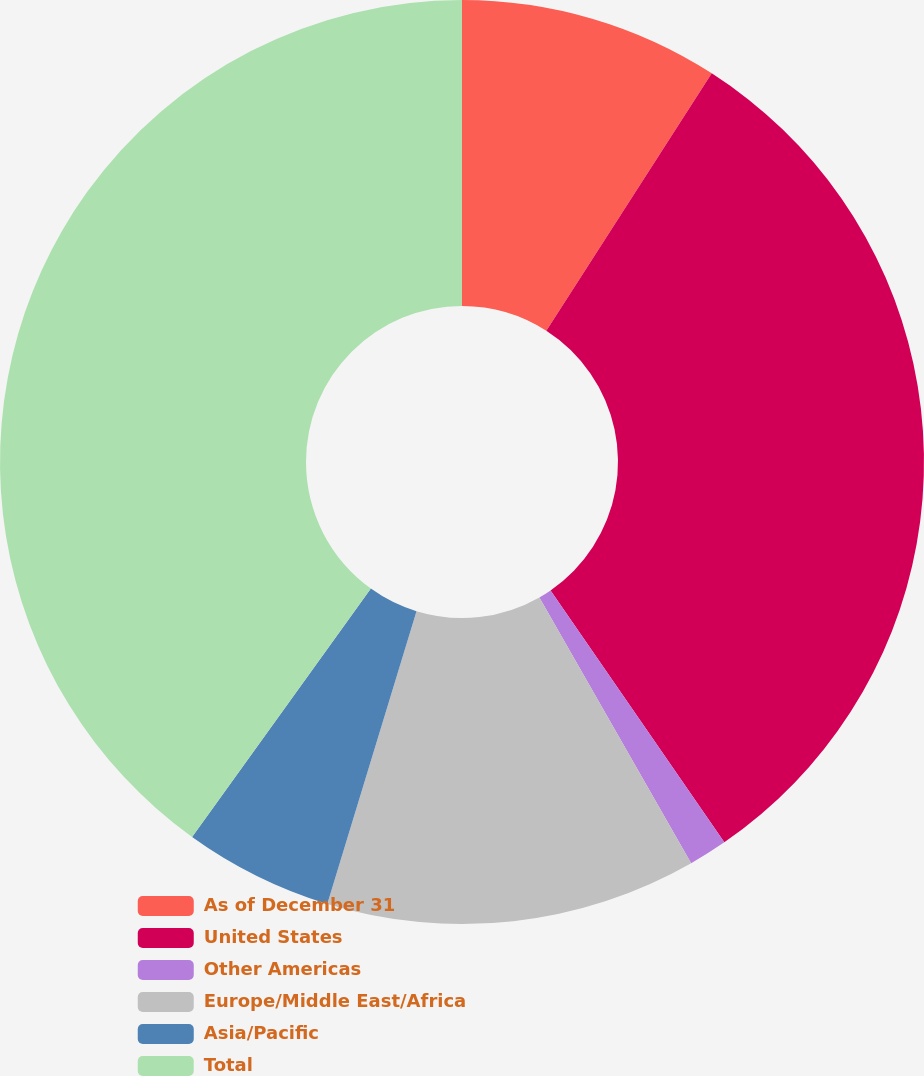Convert chart. <chart><loc_0><loc_0><loc_500><loc_500><pie_chart><fcel>As of December 31<fcel>United States<fcel>Other Americas<fcel>Europe/Middle East/Africa<fcel>Asia/Pacific<fcel>Total<nl><fcel>9.09%<fcel>31.3%<fcel>1.35%<fcel>12.97%<fcel>5.22%<fcel>40.07%<nl></chart> 